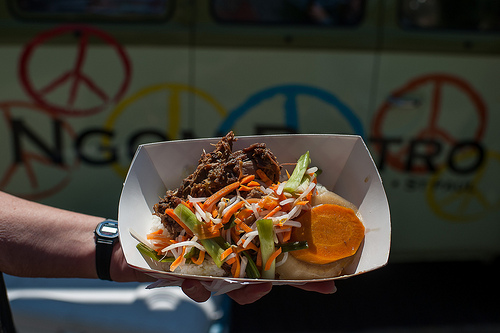<image>
Is the carrot next to the watch? No. The carrot is not positioned next to the watch. They are located in different areas of the scene. 